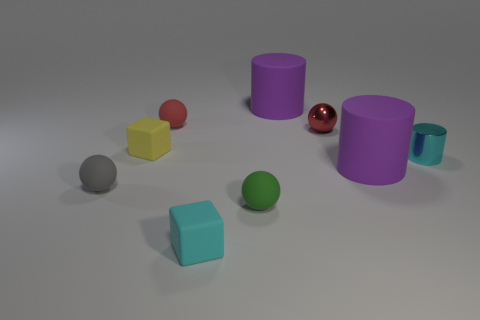There is a cyan cylinder that is the same size as the yellow object; what is its material?
Your answer should be compact. Metal. Is there a cylinder left of the cyan object behind the small gray rubber ball?
Ensure brevity in your answer.  Yes. What is the size of the green matte sphere?
Offer a terse response. Small. Are any cyan blocks visible?
Offer a terse response. Yes. Is the number of large purple rubber objects left of the small green matte sphere greater than the number of tiny rubber balls in front of the red metal ball?
Your answer should be compact. No. There is a tiny sphere that is both behind the small green sphere and on the right side of the cyan rubber block; what is its material?
Offer a terse response. Metal. Do the small yellow matte object and the small gray rubber object have the same shape?
Ensure brevity in your answer.  No. Is there any other thing that has the same size as the cyan shiny cylinder?
Keep it short and to the point. Yes. There is a yellow block; how many green matte objects are in front of it?
Ensure brevity in your answer.  1. Do the block that is behind the gray ball and the small gray matte ball have the same size?
Keep it short and to the point. Yes. 